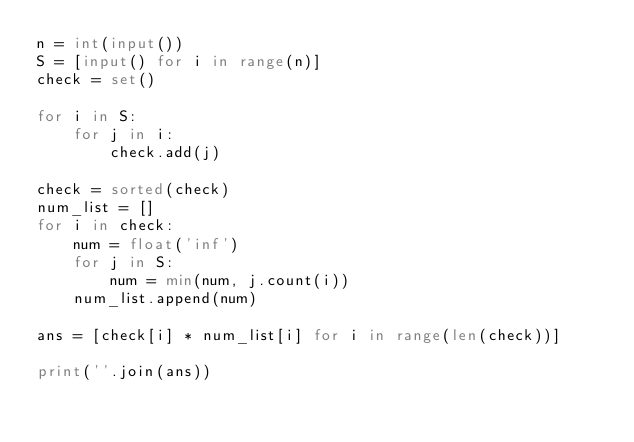<code> <loc_0><loc_0><loc_500><loc_500><_Python_>n = int(input())
S = [input() for i in range(n)]
check = set()

for i in S:
    for j in i:
        check.add(j)

check = sorted(check)
num_list = []
for i in check:
    num = float('inf')
    for j in S:
        num = min(num, j.count(i))
    num_list.append(num)

ans = [check[i] * num_list[i] for i in range(len(check))]

print(''.join(ans))</code> 